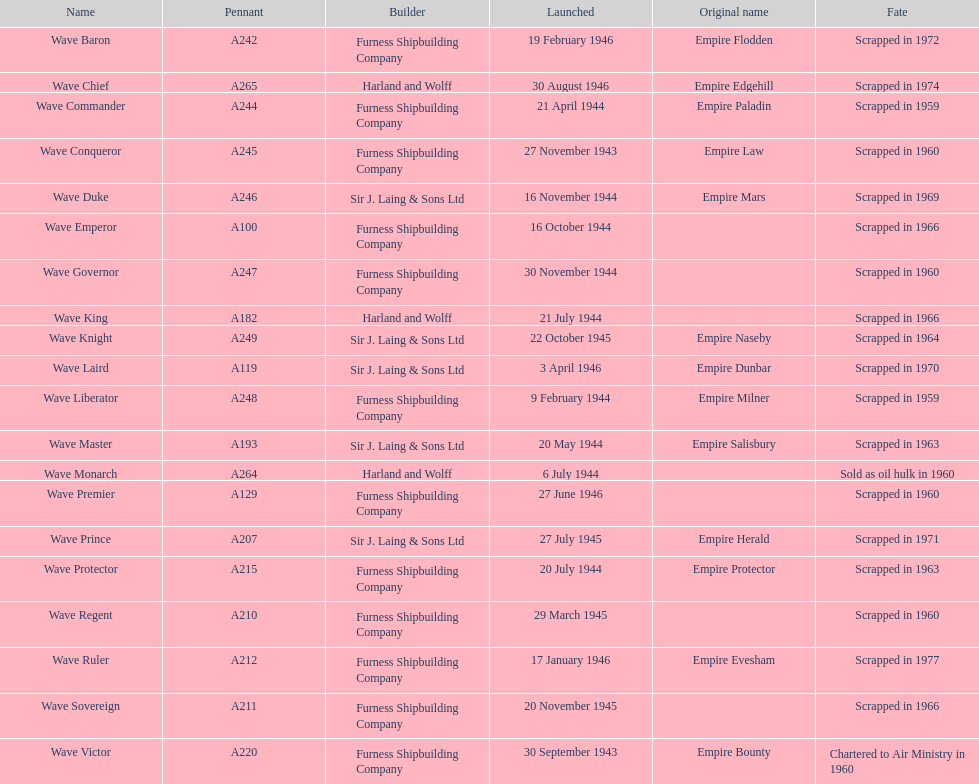How many ships were launched in the year 1944? 9. 